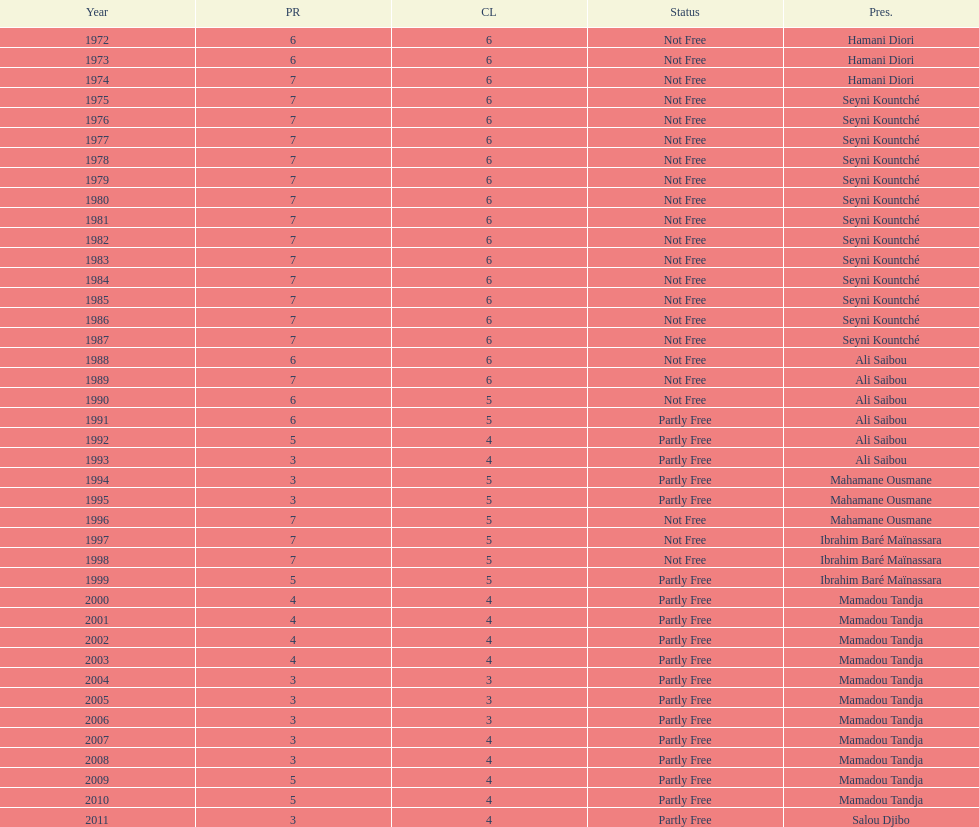How many times was the political rights listed as seven? 18. 